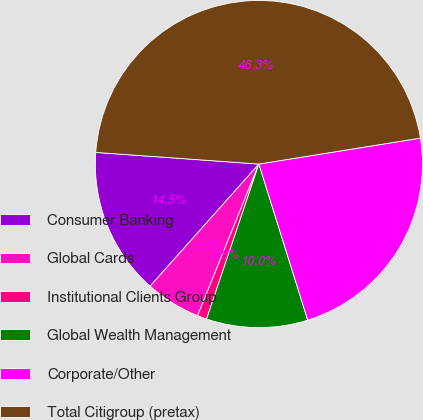Convert chart to OTSL. <chart><loc_0><loc_0><loc_500><loc_500><pie_chart><fcel>Consumer Banking<fcel>Global Cards<fcel>Institutional Clients Group<fcel>Global Wealth Management<fcel>Corporate/Other<fcel>Total Citigroup (pretax)<nl><fcel>14.55%<fcel>5.47%<fcel>0.93%<fcel>10.01%<fcel>22.71%<fcel>46.34%<nl></chart> 